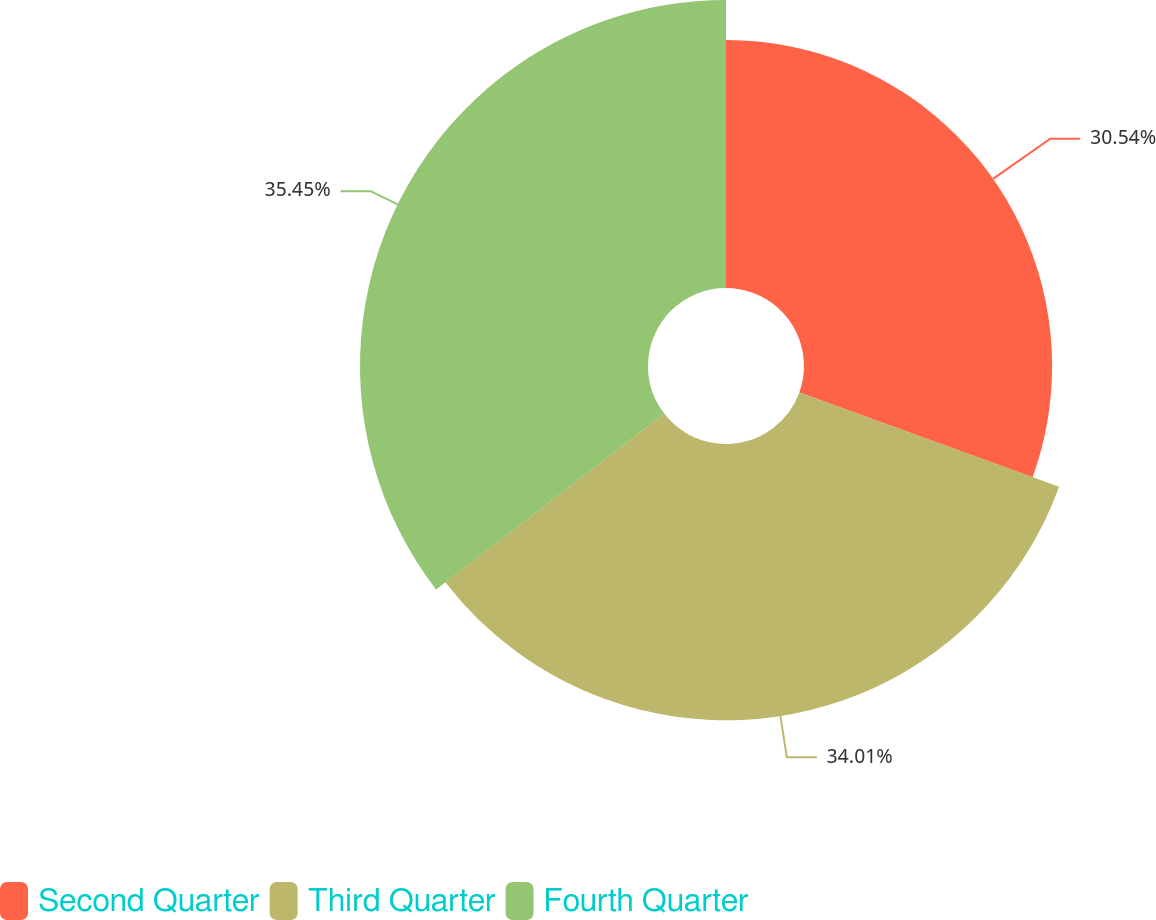<chart> <loc_0><loc_0><loc_500><loc_500><pie_chart><fcel>Second Quarter<fcel>Third Quarter<fcel>Fourth Quarter<nl><fcel>30.54%<fcel>34.01%<fcel>35.45%<nl></chart> 